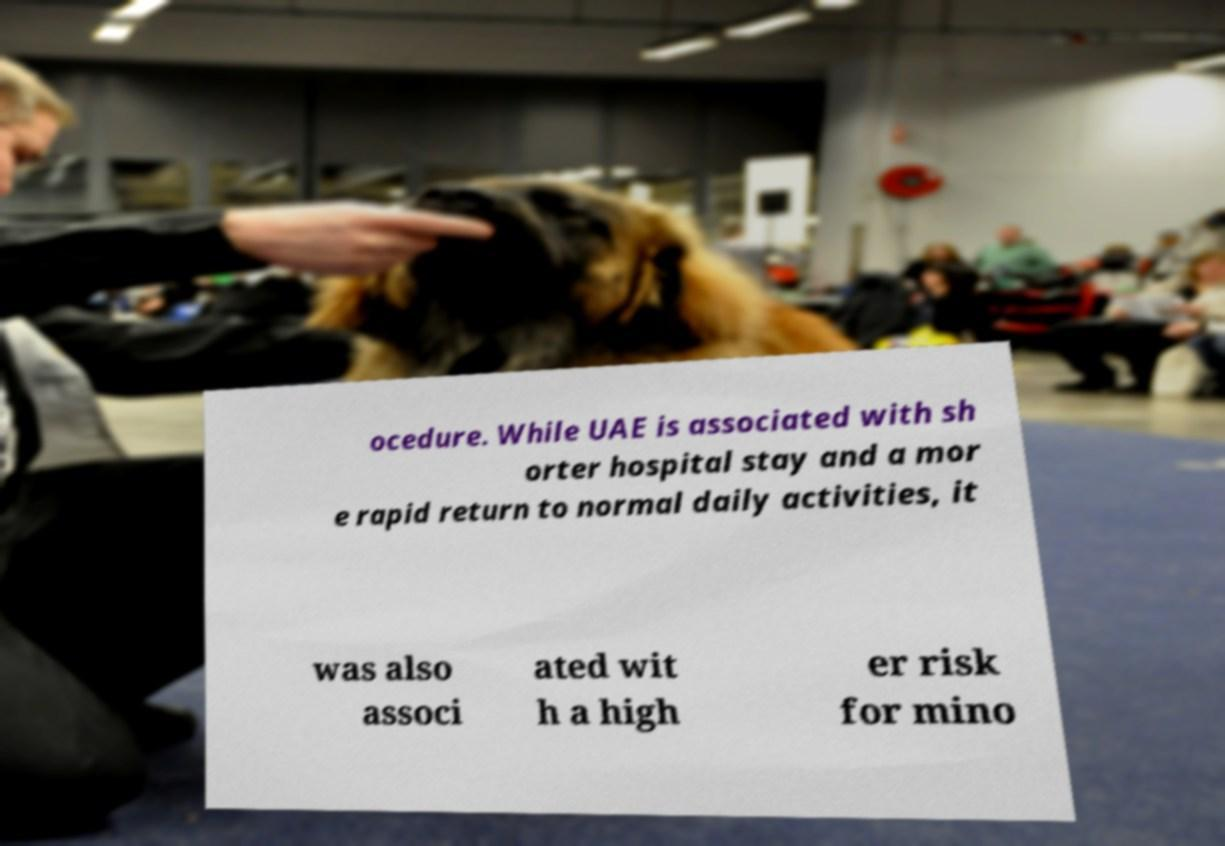Could you assist in decoding the text presented in this image and type it out clearly? ocedure. While UAE is associated with sh orter hospital stay and a mor e rapid return to normal daily activities, it was also associ ated wit h a high er risk for mino 